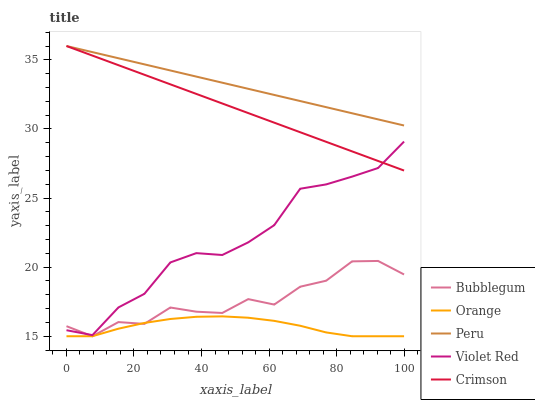Does Orange have the minimum area under the curve?
Answer yes or no. Yes. Does Peru have the maximum area under the curve?
Answer yes or no. Yes. Does Crimson have the minimum area under the curve?
Answer yes or no. No. Does Crimson have the maximum area under the curve?
Answer yes or no. No. Is Peru the smoothest?
Answer yes or no. Yes. Is Bubblegum the roughest?
Answer yes or no. Yes. Is Crimson the smoothest?
Answer yes or no. No. Is Crimson the roughest?
Answer yes or no. No. Does Orange have the lowest value?
Answer yes or no. Yes. Does Crimson have the lowest value?
Answer yes or no. No. Does Peru have the highest value?
Answer yes or no. Yes. Does Violet Red have the highest value?
Answer yes or no. No. Is Bubblegum less than Peru?
Answer yes or no. Yes. Is Violet Red greater than Orange?
Answer yes or no. Yes. Does Peru intersect Crimson?
Answer yes or no. Yes. Is Peru less than Crimson?
Answer yes or no. No. Is Peru greater than Crimson?
Answer yes or no. No. Does Bubblegum intersect Peru?
Answer yes or no. No. 